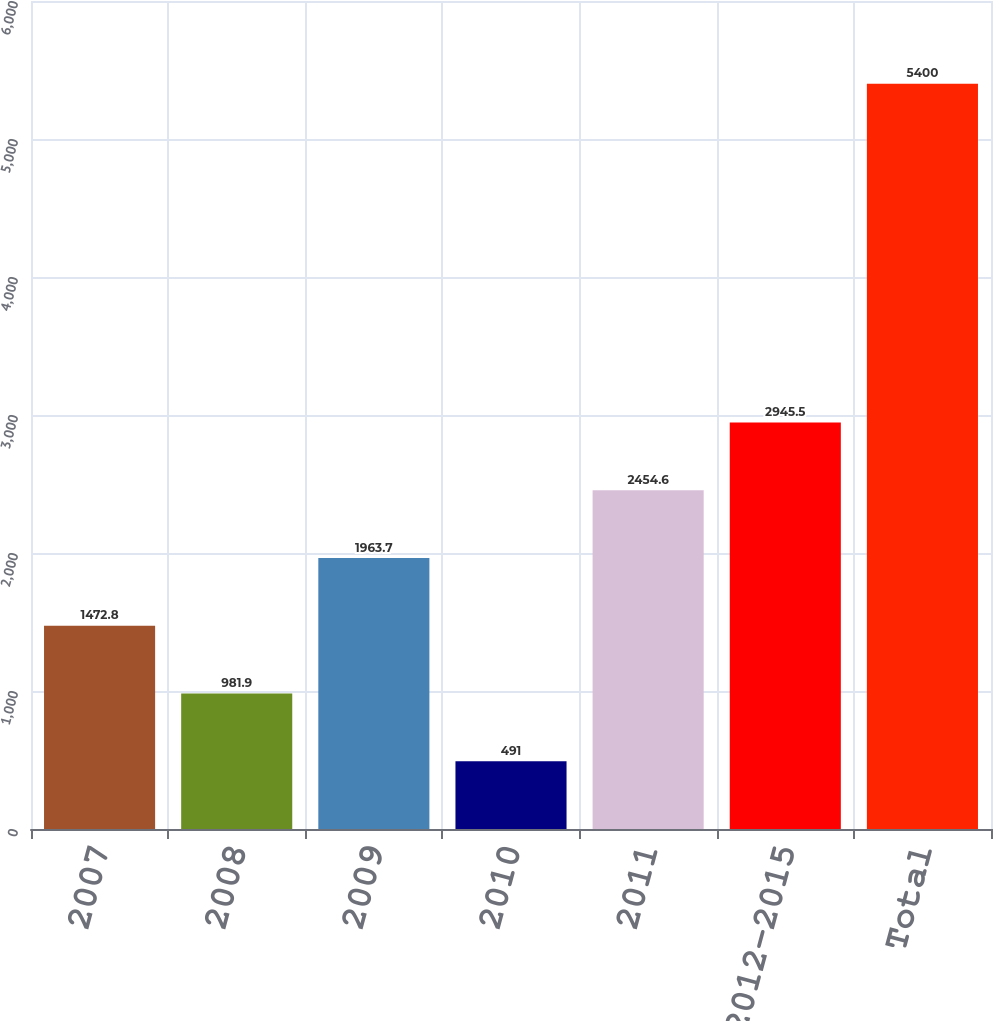Convert chart to OTSL. <chart><loc_0><loc_0><loc_500><loc_500><bar_chart><fcel>2007<fcel>2008<fcel>2009<fcel>2010<fcel>2011<fcel>2012-2015<fcel>Total<nl><fcel>1472.8<fcel>981.9<fcel>1963.7<fcel>491<fcel>2454.6<fcel>2945.5<fcel>5400<nl></chart> 